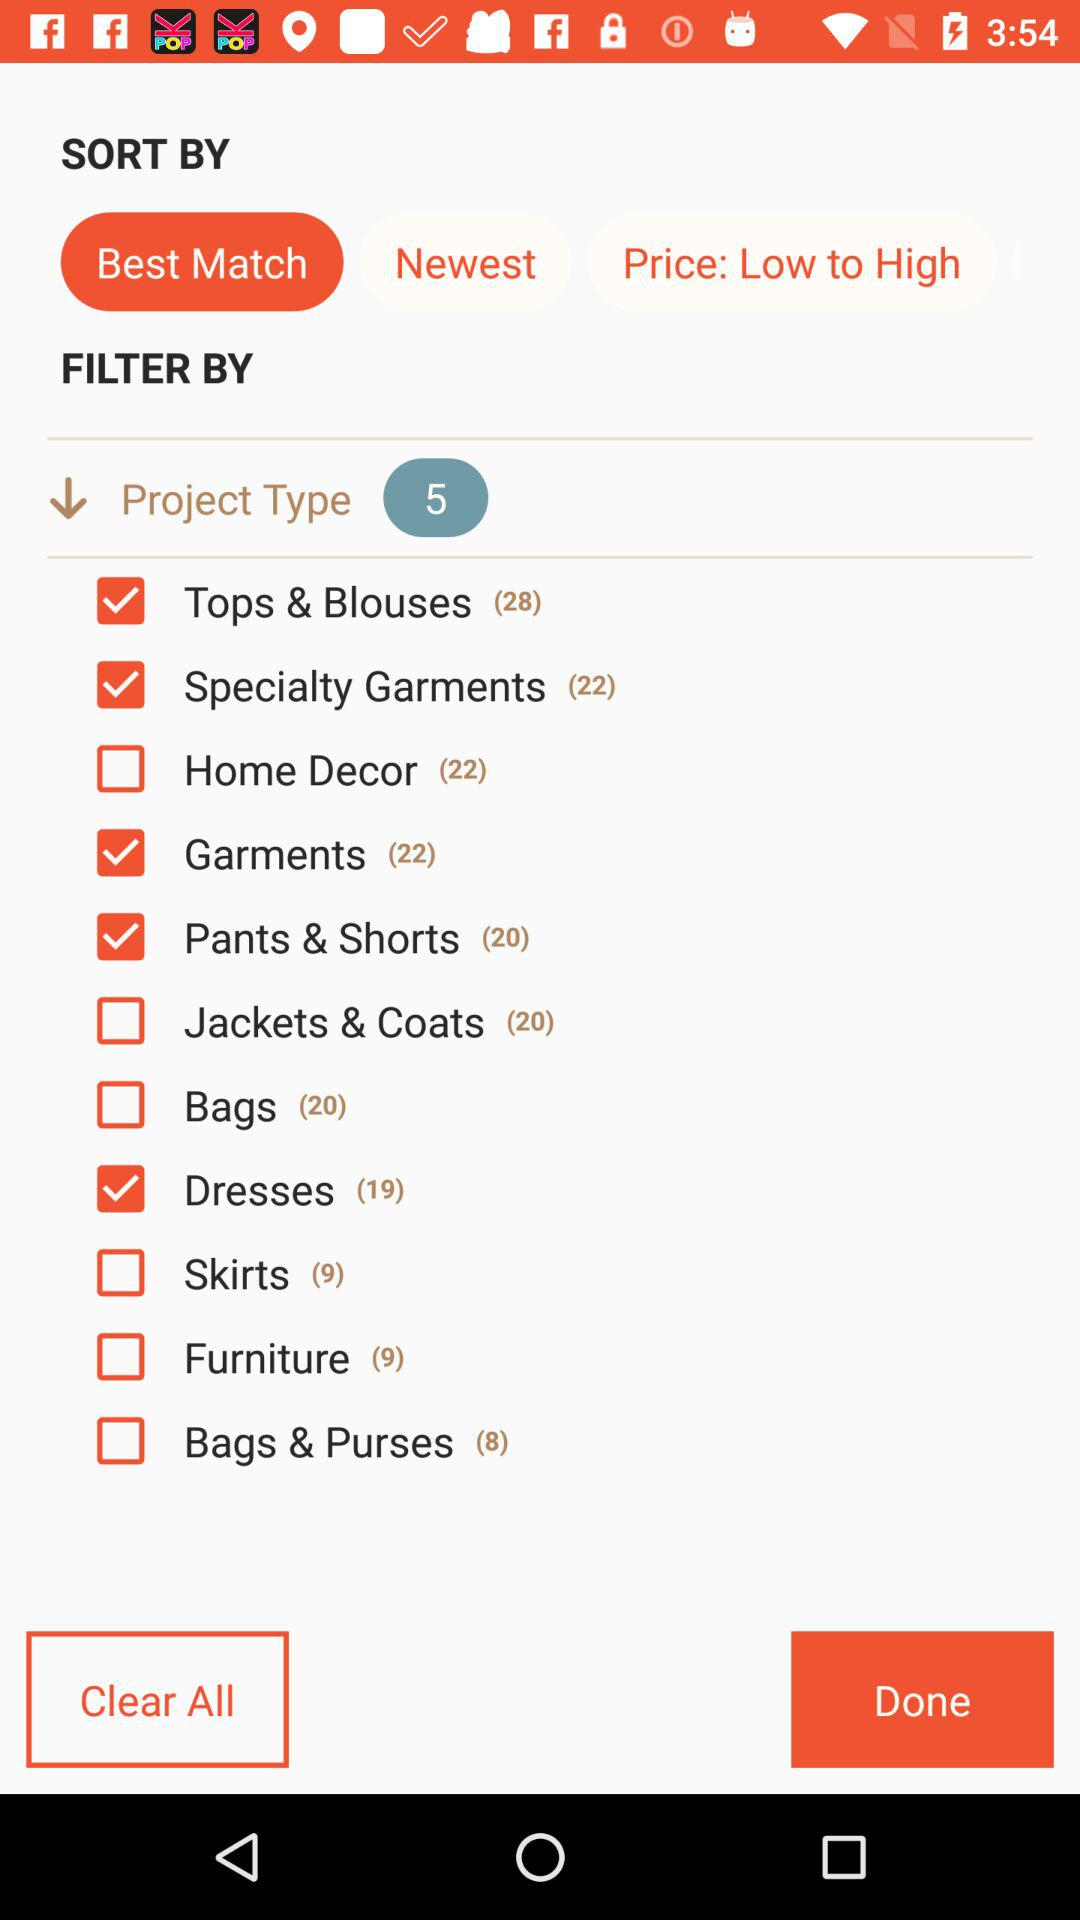Which "SORT BY" option is selected? The selected option is "Best Match". 